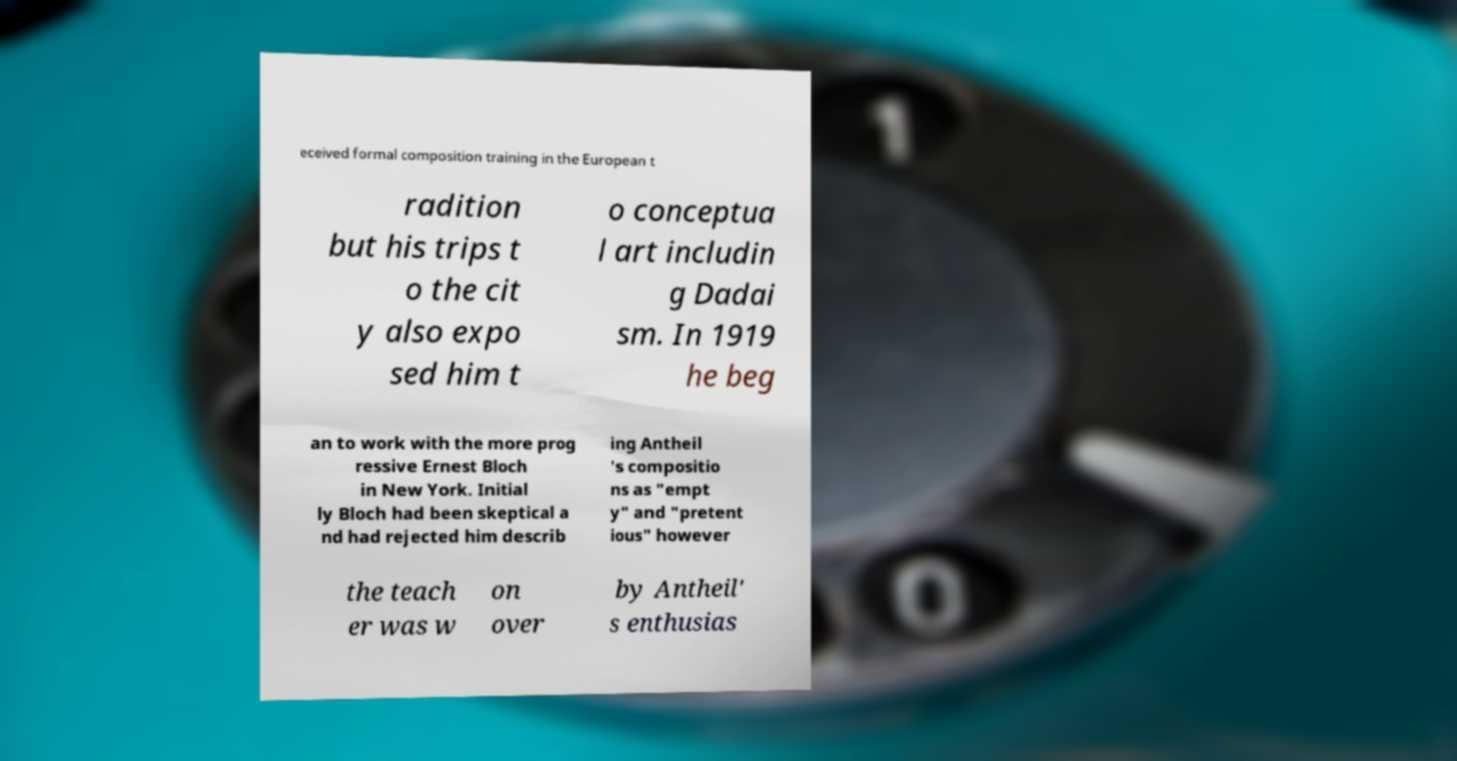Can you read and provide the text displayed in the image?This photo seems to have some interesting text. Can you extract and type it out for me? eceived formal composition training in the European t radition but his trips t o the cit y also expo sed him t o conceptua l art includin g Dadai sm. In 1919 he beg an to work with the more prog ressive Ernest Bloch in New York. Initial ly Bloch had been skeptical a nd had rejected him describ ing Antheil 's compositio ns as "empt y" and "pretent ious" however the teach er was w on over by Antheil' s enthusias 